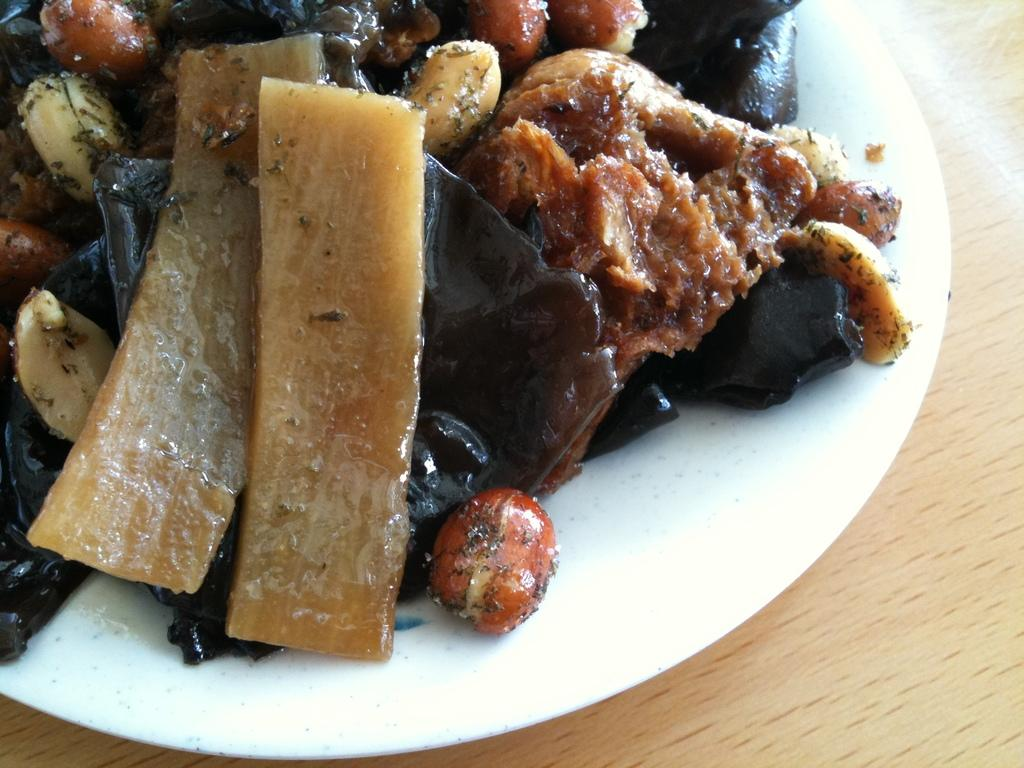What type of surface is visible in the image? There is a wooden surface in the image. What is placed on the wooden surface? There is a plate on the wooden surface. What is contained within the plate? The plate contains food items, including peanuts. Are there any other food items in the plate besides peanuts? Yes, there are other unspecified food items in the plate. What type of disease can be seen affecting the snail in the image? There is no snail present in the image, and therefore no disease can be observed. 